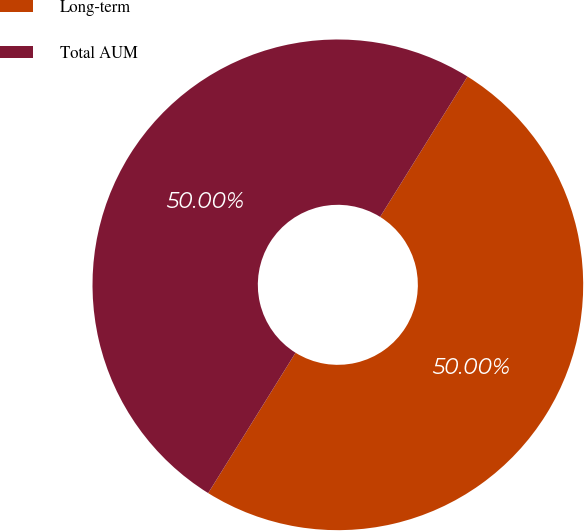Convert chart to OTSL. <chart><loc_0><loc_0><loc_500><loc_500><pie_chart><fcel>Long-term<fcel>Total AUM<nl><fcel>50.0%<fcel>50.0%<nl></chart> 